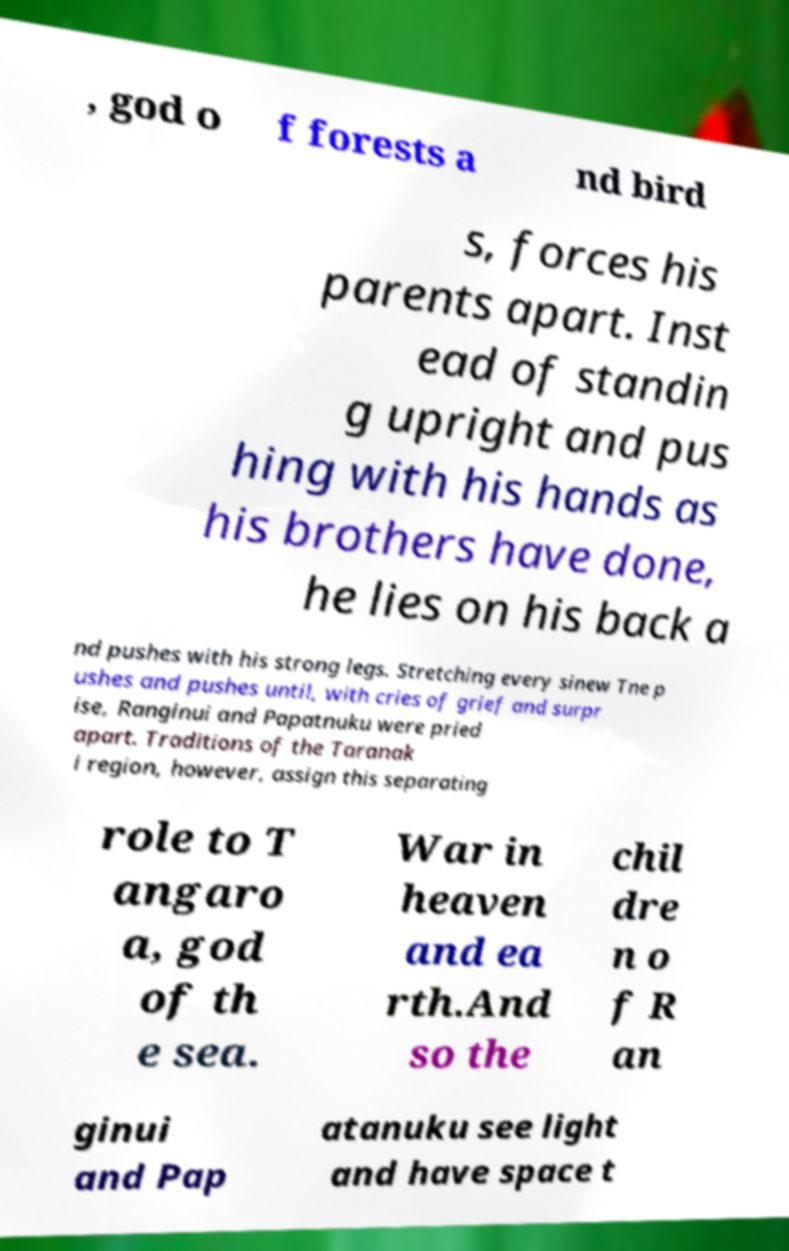Could you extract and type out the text from this image? , god o f forests a nd bird s, forces his parents apart. Inst ead of standin g upright and pus hing with his hands as his brothers have done, he lies on his back a nd pushes with his strong legs. Stretching every sinew Tne p ushes and pushes until, with cries of grief and surpr ise, Ranginui and Papatnuku were pried apart. Traditions of the Taranak i region, however, assign this separating role to T angaro a, god of th e sea. War in heaven and ea rth.And so the chil dre n o f R an ginui and Pap atanuku see light and have space t 